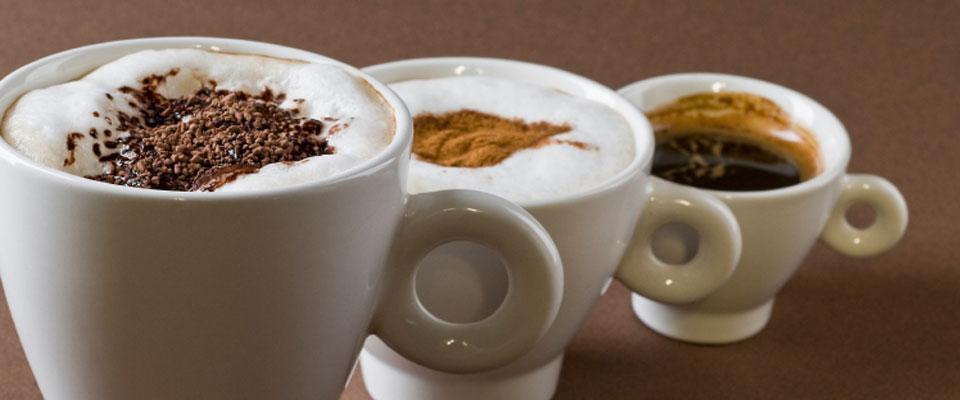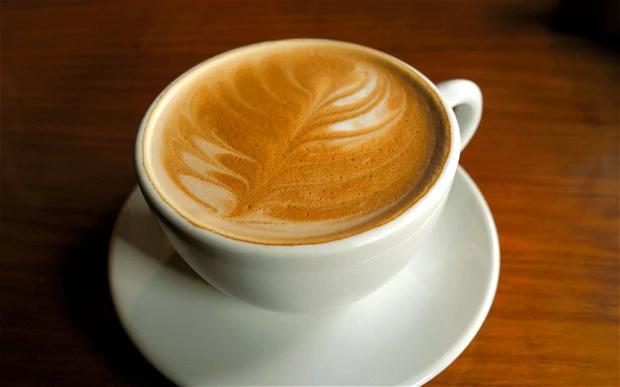The first image is the image on the left, the second image is the image on the right. Evaluate the accuracy of this statement regarding the images: "There are three mugs filled with a cafe drink in the image on the left.". Is it true? Answer yes or no. Yes. The first image is the image on the left, the second image is the image on the right. Given the left and right images, does the statement "There are at least three coffee cups in the left image." hold true? Answer yes or no. Yes. 